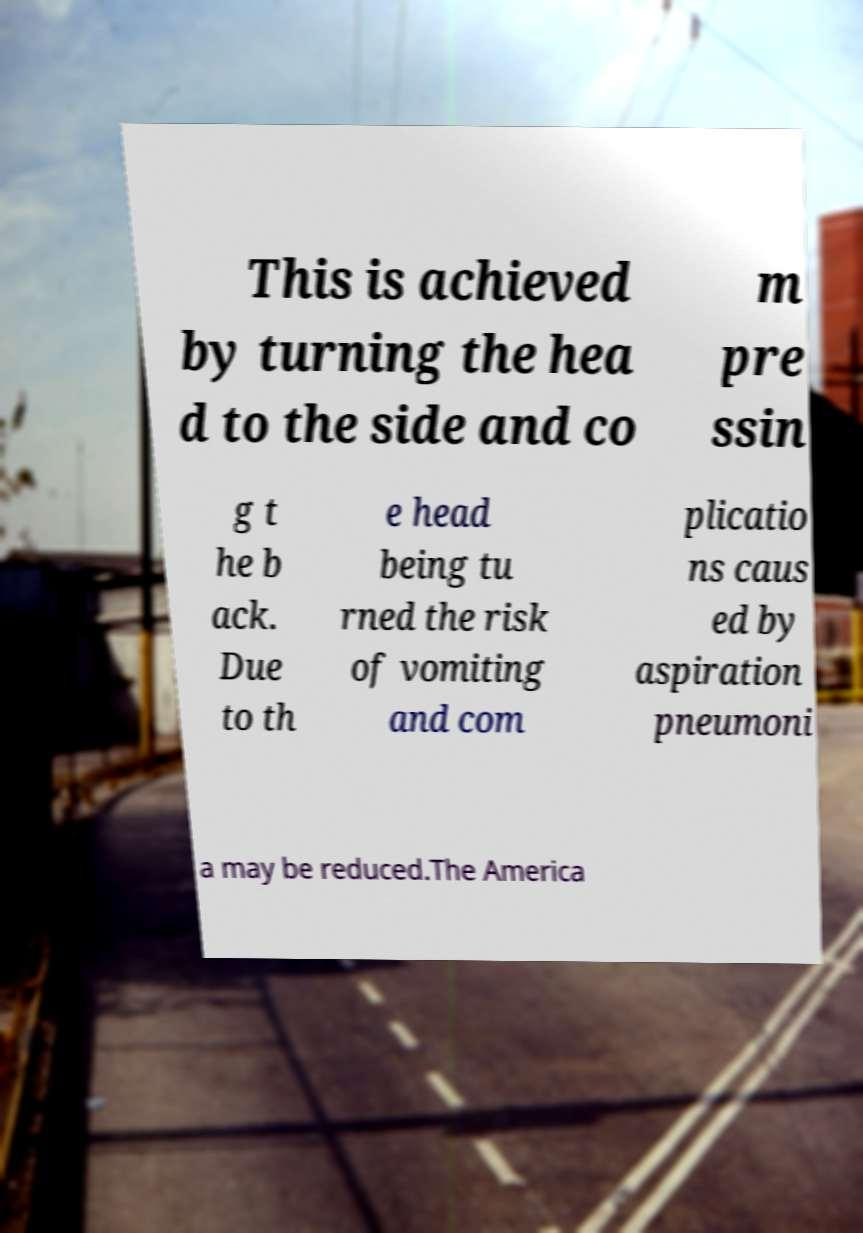There's text embedded in this image that I need extracted. Can you transcribe it verbatim? This is achieved by turning the hea d to the side and co m pre ssin g t he b ack. Due to th e head being tu rned the risk of vomiting and com plicatio ns caus ed by aspiration pneumoni a may be reduced.The America 